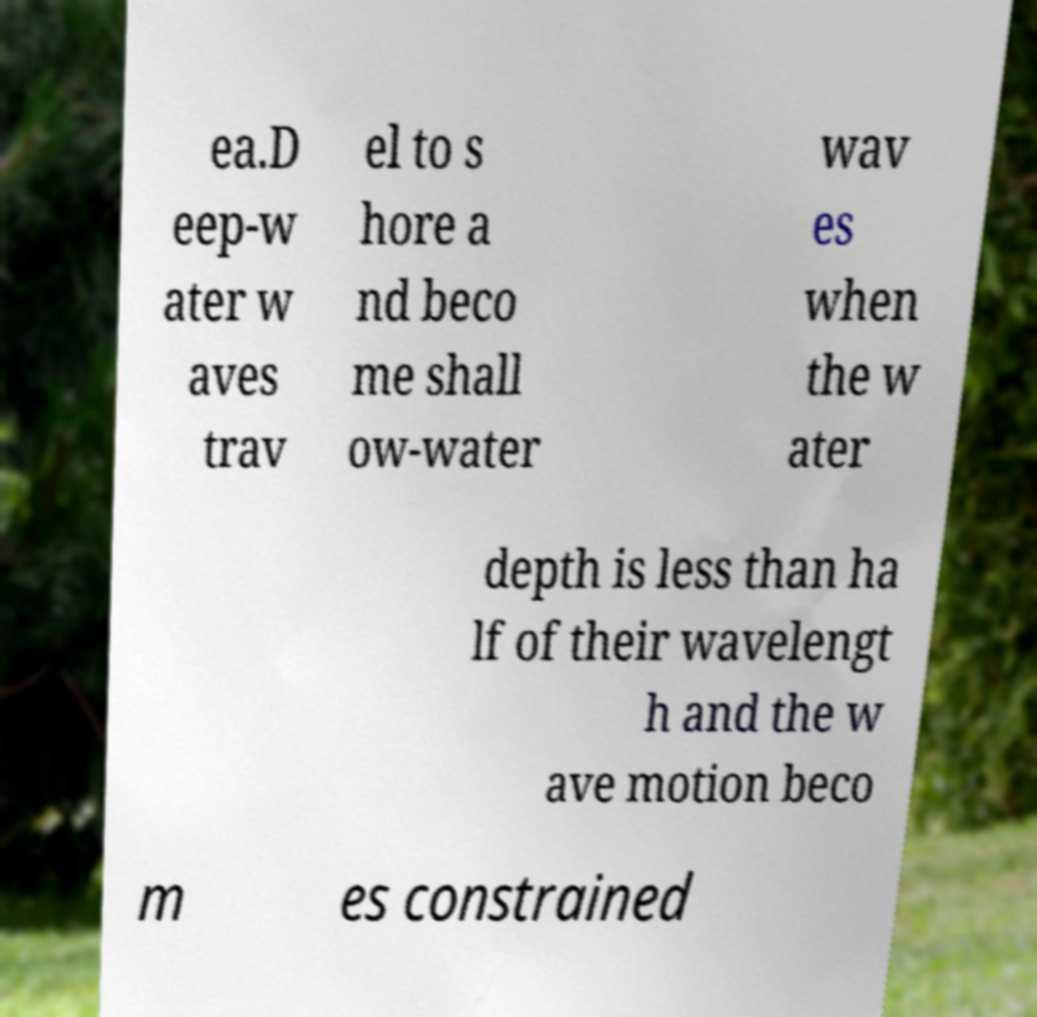Can you accurately transcribe the text from the provided image for me? ea.D eep-w ater w aves trav el to s hore a nd beco me shall ow-water wav es when the w ater depth is less than ha lf of their wavelengt h and the w ave motion beco m es constrained 